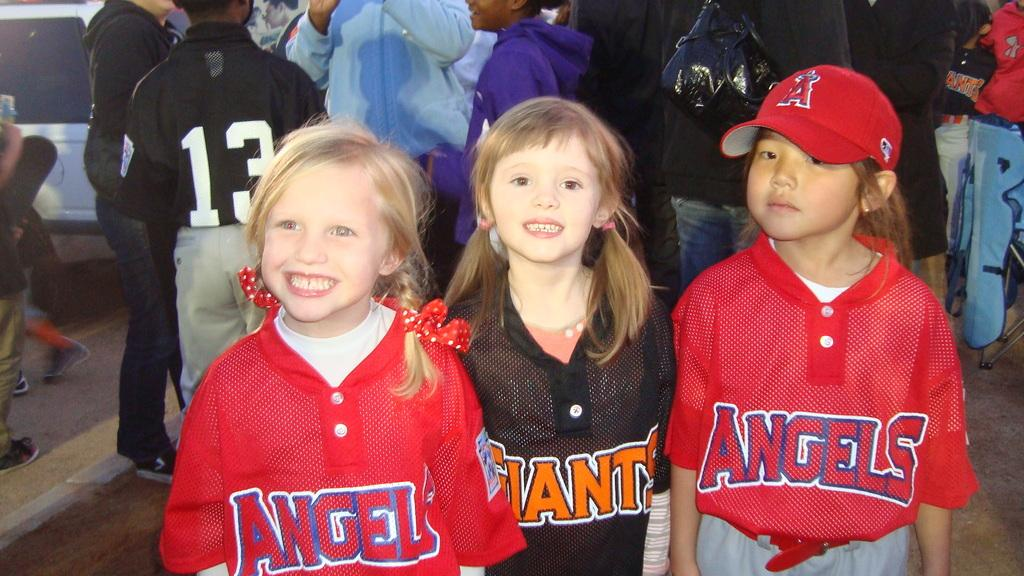<image>
Render a clear and concise summary of the photo. Several kids standing together with the words angels and giants on their jerseys. 